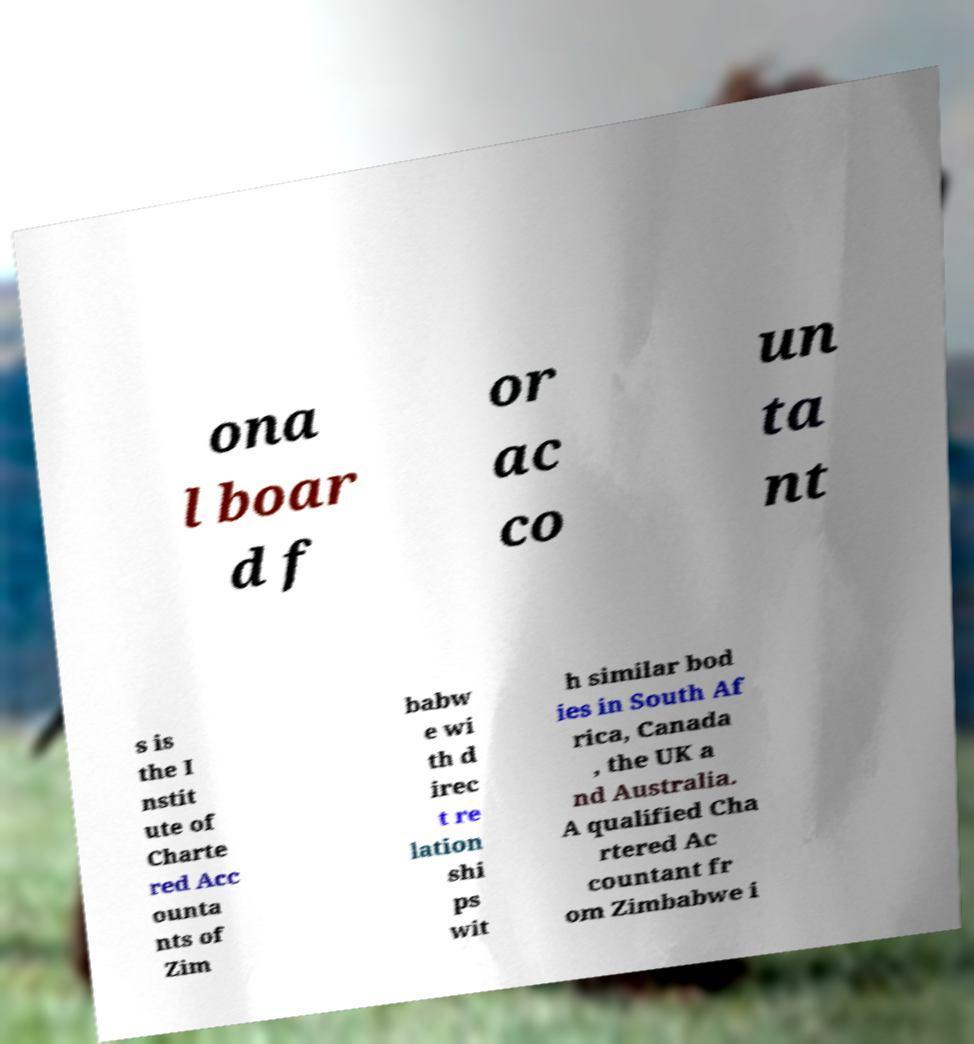Could you extract and type out the text from this image? ona l boar d f or ac co un ta nt s is the I nstit ute of Charte red Acc ounta nts of Zim babw e wi th d irec t re lation shi ps wit h similar bod ies in South Af rica, Canada , the UK a nd Australia. A qualified Cha rtered Ac countant fr om Zimbabwe i 